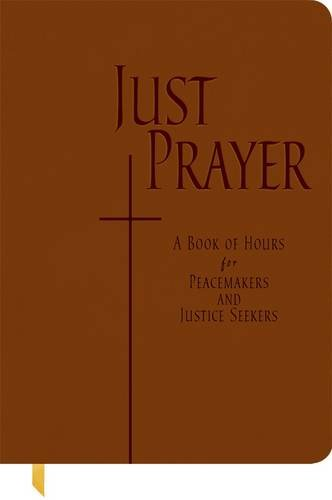Who is the author of this book? The author of 'Just Prayer: A Book of Hours for Peacemakers and Justice Seekers' is Alison M. Benders, who focuses on theological insights and spiritual practices. 